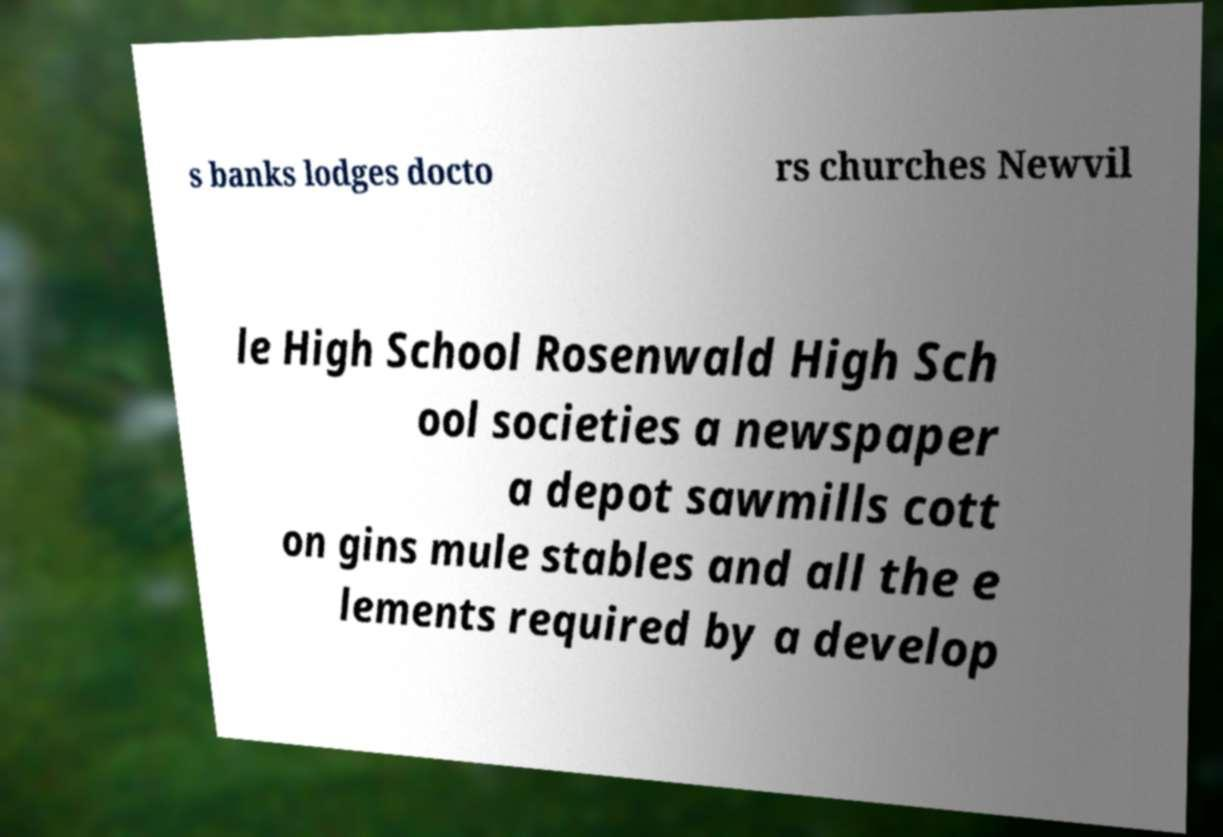What messages or text are displayed in this image? I need them in a readable, typed format. s banks lodges docto rs churches Newvil le High School Rosenwald High Sch ool societies a newspaper a depot sawmills cott on gins mule stables and all the e lements required by a develop 